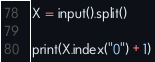Convert code to text. <code><loc_0><loc_0><loc_500><loc_500><_Python_>X = input().split()

print(X.index("0") + 1)</code> 